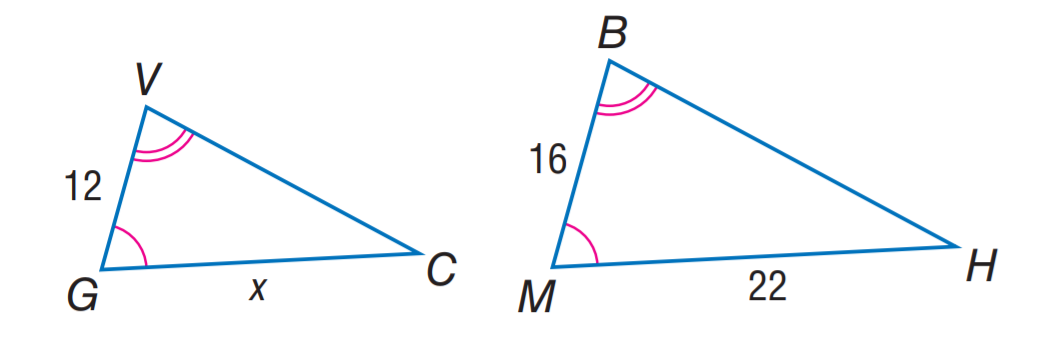Question: Two triangles are similar. Find x.
Choices:
A. 11
B. 12
C. 13.5
D. 16.5
Answer with the letter. Answer: D 